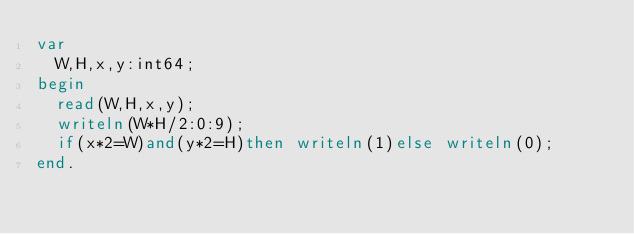<code> <loc_0><loc_0><loc_500><loc_500><_Pascal_>var
	W,H,x,y:int64;
begin
	read(W,H,x,y);
	writeln(W*H/2:0:9);
	if(x*2=W)and(y*2=H)then writeln(1)else writeln(0);
end.
</code> 